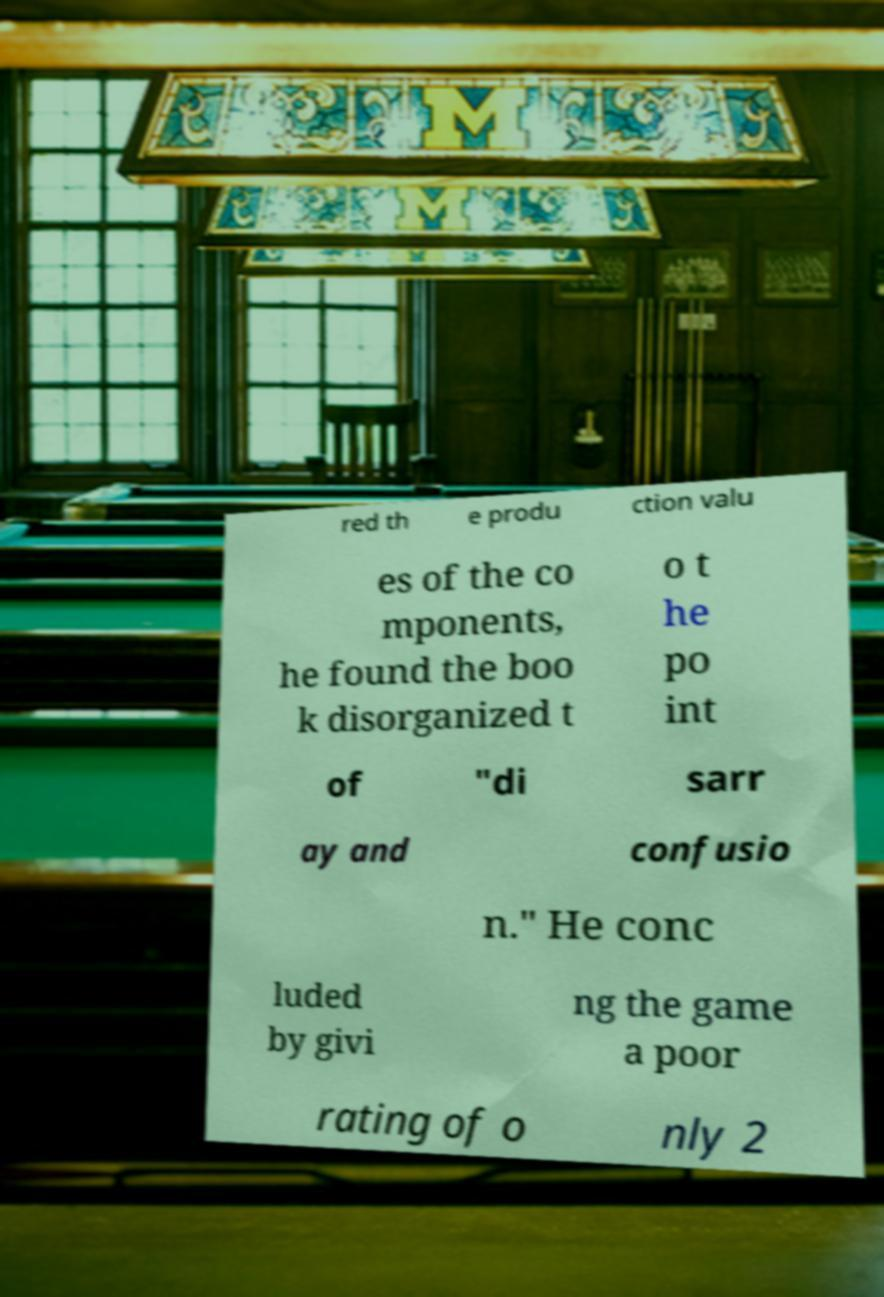Can you accurately transcribe the text from the provided image for me? red th e produ ction valu es of the co mponents, he found the boo k disorganized t o t he po int of "di sarr ay and confusio n." He conc luded by givi ng the game a poor rating of o nly 2 